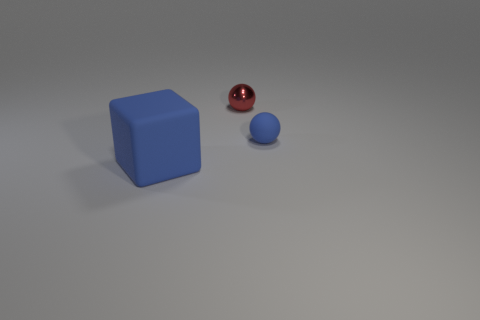What material is the sphere left of the tiny thing right of the small red ball made of?
Provide a short and direct response. Metal. What number of other red shiny objects have the same shape as the red thing?
Ensure brevity in your answer.  0. Is there another small ball of the same color as the matte ball?
Provide a succinct answer. No. How many objects are either spheres that are behind the tiny matte object or blue things behind the blue rubber block?
Ensure brevity in your answer.  2. There is a matte sphere that is right of the blue block; is there a blue object that is right of it?
Your response must be concise. No. The blue matte object that is the same size as the red sphere is what shape?
Provide a succinct answer. Sphere. How many things are small shiny spheres behind the tiny blue rubber sphere or tiny red metallic objects?
Give a very brief answer. 1. What number of other things are there of the same material as the red thing
Your response must be concise. 0. What shape is the small object that is the same color as the cube?
Offer a very short reply. Sphere. How big is the matte object that is behind the large object?
Your answer should be compact. Small. 